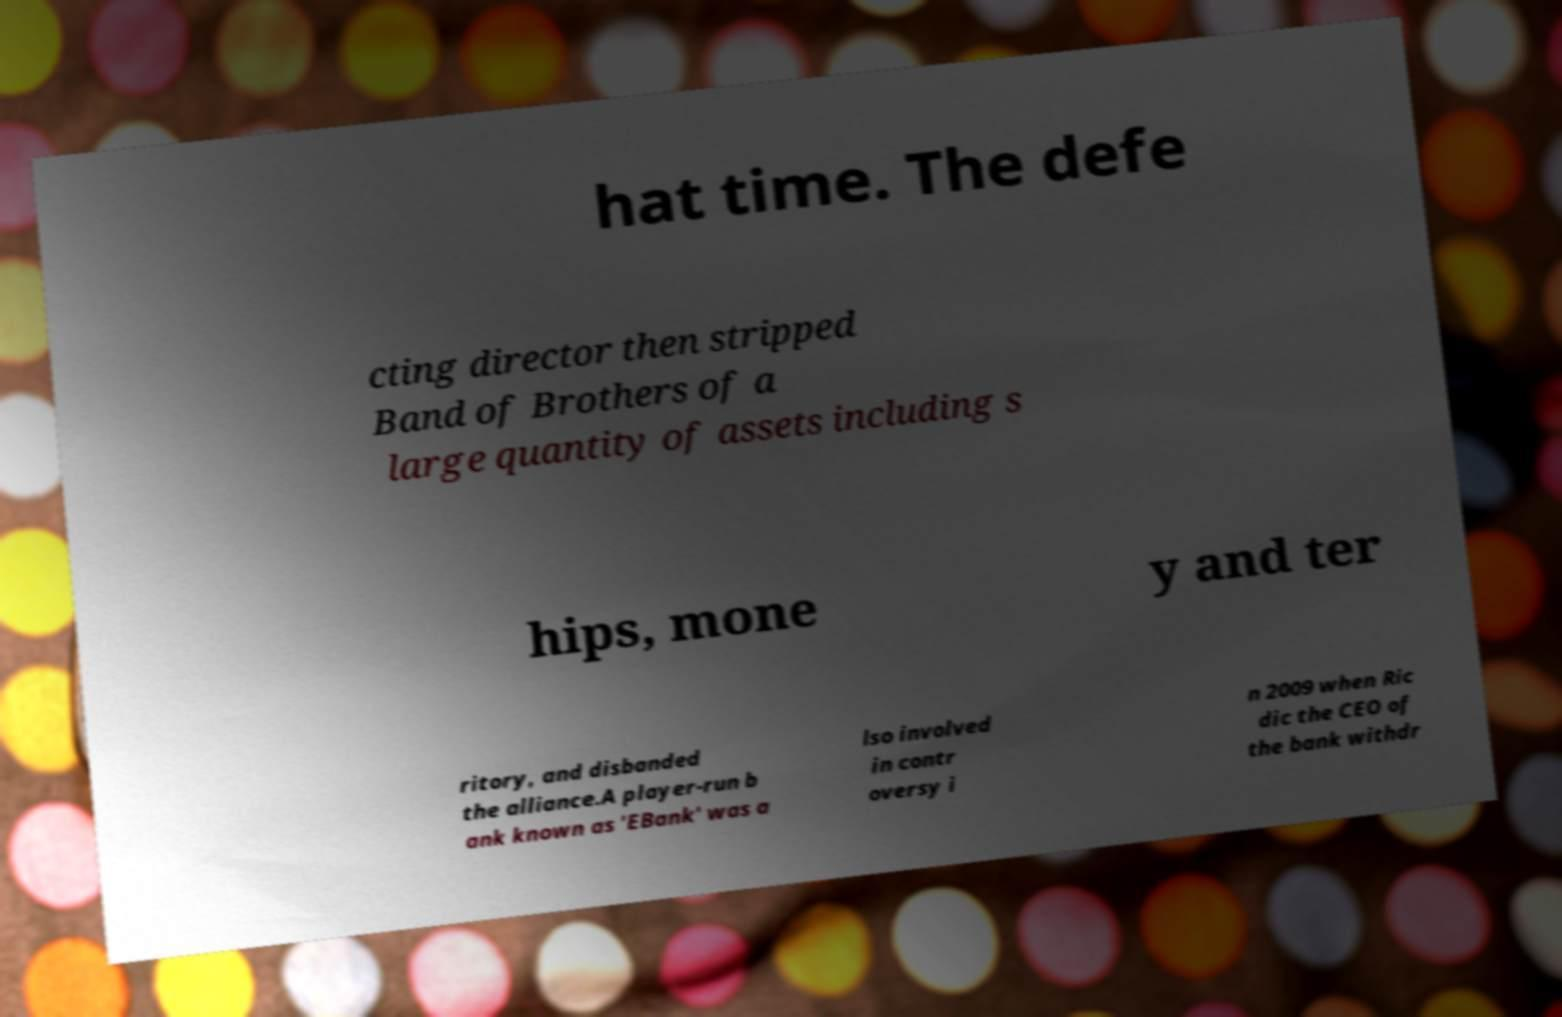Please read and relay the text visible in this image. What does it say? hat time. The defe cting director then stripped Band of Brothers of a large quantity of assets including s hips, mone y and ter ritory, and disbanded the alliance.A player-run b ank known as 'EBank' was a lso involved in contr oversy i n 2009 when Ric dic the CEO of the bank withdr 